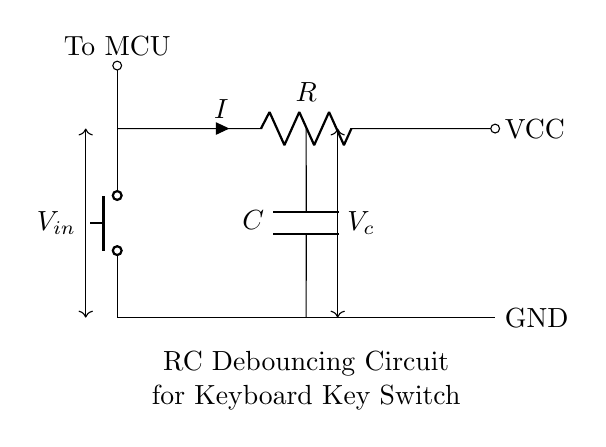What is the type of key switch used in this circuit? The circuit diagram indicates a push button switch is employed, as shown in the schematic.
Answer: push button What components are present in this RC debouncing circuit? The circuit comprises a resistor and a capacitor in addition to the key switch. The resistor is indicated with "R" and the capacitor with "C."
Answer: resistor and capacitor What is the expected behavior of the output voltage when the key switch is pressed? When the switch is pressed, the capacitor charges through the resistor, causing the output voltage to rise gradually rather than instantaneously, which helps in debouncing.
Answer: gradual rise What is the role of the resistor in this circuit? The resistor limits the charging current to the capacitor and affects the time constant of the RC circuit, which determines how quickly the capacitor charges and discharges.
Answer: limits charging current What is the relationship between the resistance and capacitance in this circuit for determining the time constant? The time constant, represented as tau (τ), is given by the product of resistance (R) and capacitance (C) in this RC circuit: τ = R × C. This relationship indicates how quickly the capacitor will charge and discharge.
Answer: τ = R × C What happens to the voltage across the capacitor when the key switch is released? Upon releasing the switch, the capacitor discharges through the resistor, causing the voltage across the capacitor to decrease over time, following an exponential decay curve.
Answer: decreases over time 